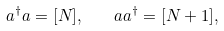Convert formula to latex. <formula><loc_0><loc_0><loc_500><loc_500>a ^ { \dagger } a = [ N ] , \quad a a ^ { \dagger } = [ N + 1 ] ,</formula> 